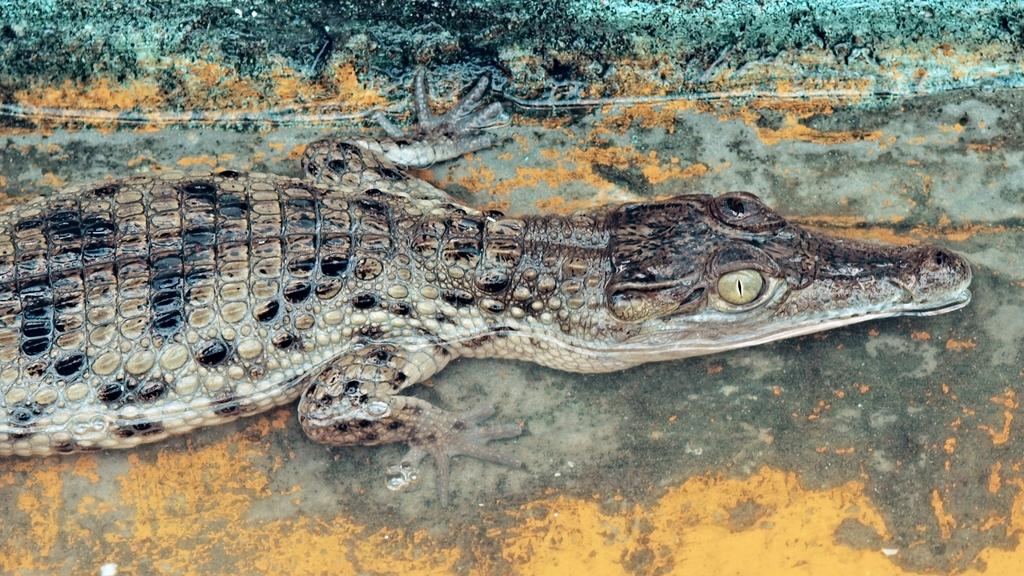What type of animal is in the image? There is a crocodile in the image. What type of songs can be heard being sung by the man in the image? There is no man present in the image, and therefore no songs can be heard. 